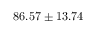<formula> <loc_0><loc_0><loc_500><loc_500>8 6 . 5 7 \pm 1 3 . 7 4</formula> 